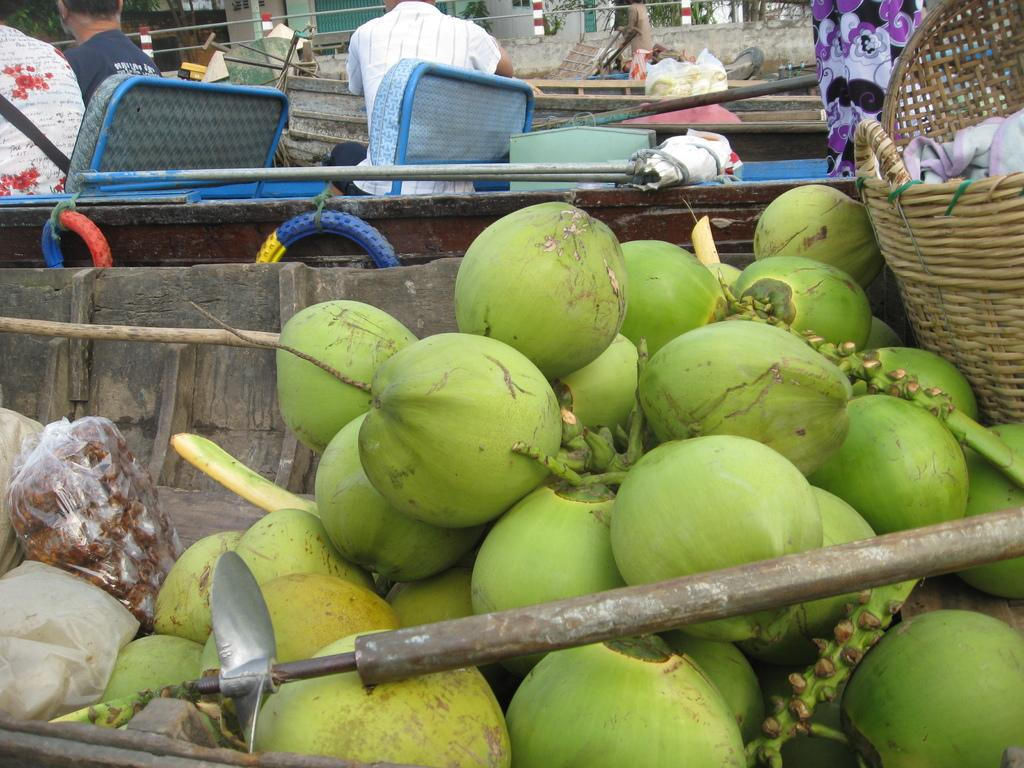What type of fruit can be seen in the image? There are coconuts in the image. What objects are used for carrying or holding items in the image? There are baskets and packets in the image. What type of equipment is present in the image? There are tires in the image. What are the people in the image doing? There are people sitting on chairs in the image. What structures can be seen in the image? There are poles in the image. What type of material is present in the image? There are ropes in the image. What tool can be seen in the image? There is an axe in the image. What is the distance between the sail and the plantation in the image? There is no sail or plantation present in the image. What type of plantation can be seen in the image? There is no plantation present in the image. 